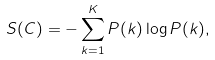<formula> <loc_0><loc_0><loc_500><loc_500>S ( C ) = - \sum _ { k = 1 } ^ { K } P ( k ) \log P ( k ) ,</formula> 